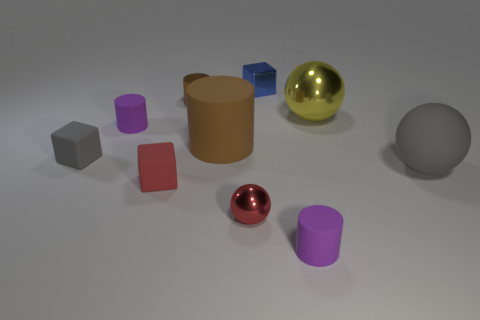Subtract all blocks. How many objects are left? 7 Add 6 large gray metallic objects. How many large gray metallic objects exist? 6 Subtract 2 brown cylinders. How many objects are left? 8 Subtract all tiny purple rubber cylinders. Subtract all big gray matte spheres. How many objects are left? 7 Add 1 red rubber blocks. How many red rubber blocks are left? 2 